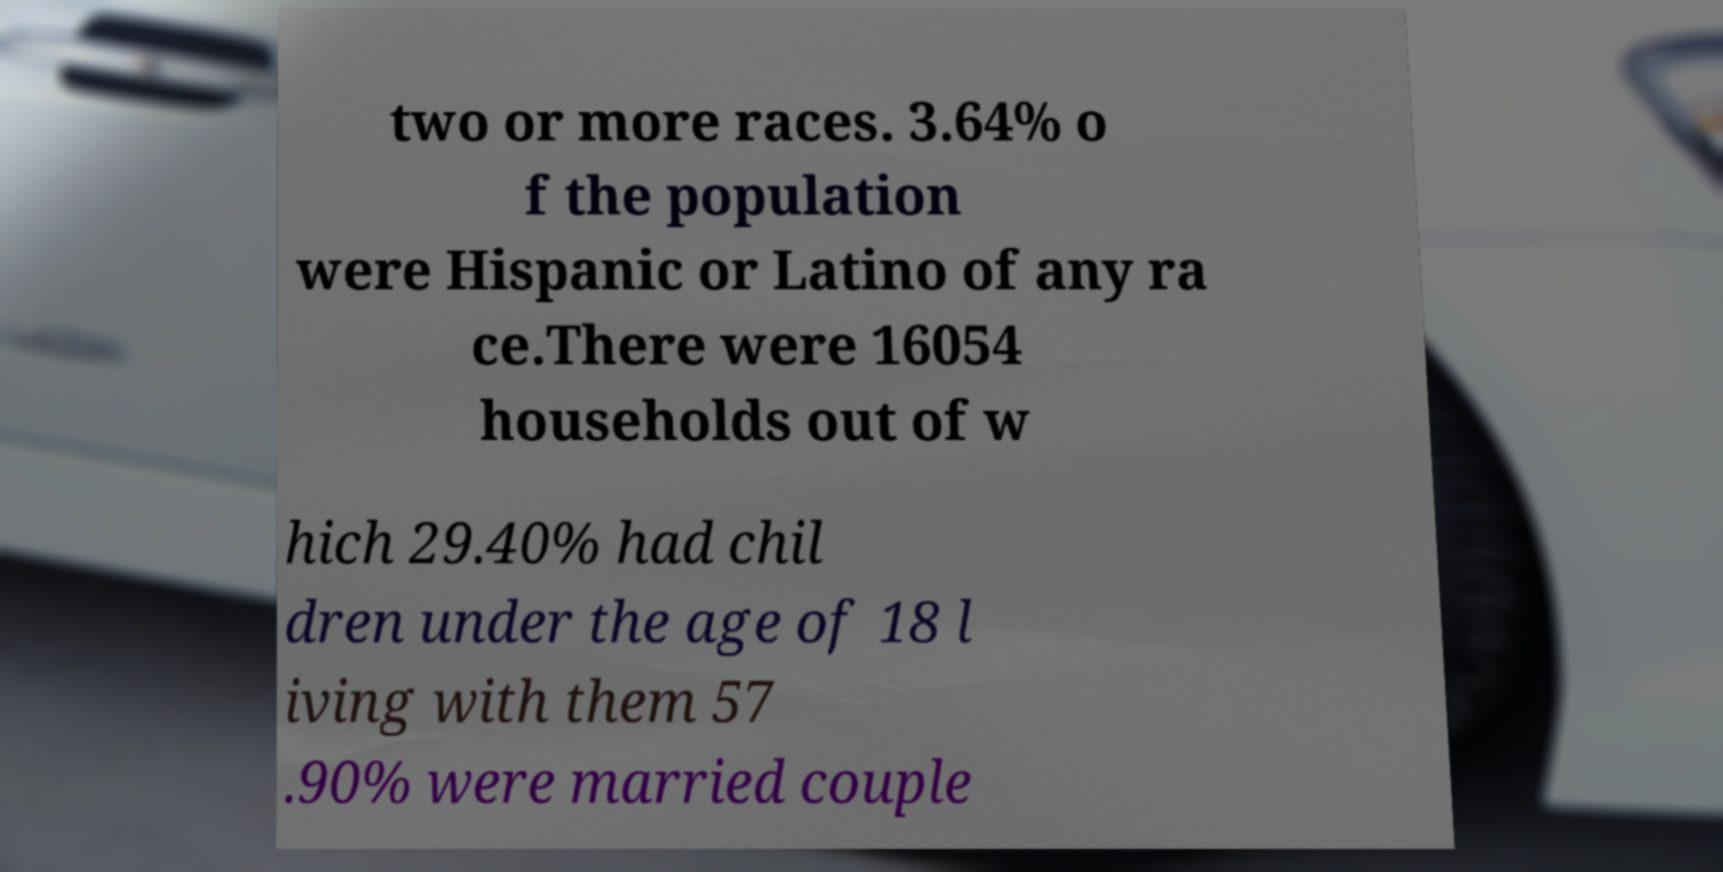There's text embedded in this image that I need extracted. Can you transcribe it verbatim? two or more races. 3.64% o f the population were Hispanic or Latino of any ra ce.There were 16054 households out of w hich 29.40% had chil dren under the age of 18 l iving with them 57 .90% were married couple 